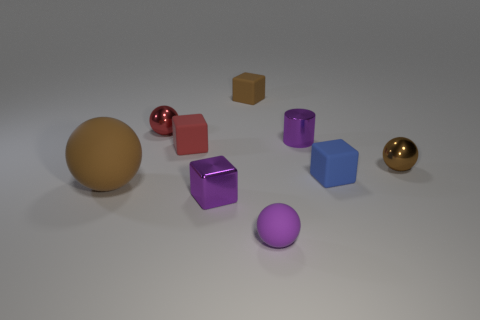Subtract all brown matte cubes. How many cubes are left? 3 Subtract all gray cylinders. How many brown spheres are left? 2 Add 1 tiny metallic things. How many objects exist? 10 Subtract all purple balls. How many balls are left? 3 Subtract all cylinders. How many objects are left? 8 Subtract 1 balls. How many balls are left? 3 Subtract 0 yellow balls. How many objects are left? 9 Subtract all blue spheres. Subtract all yellow cylinders. How many spheres are left? 4 Subtract all brown rubber cylinders. Subtract all purple metallic things. How many objects are left? 7 Add 7 blue matte blocks. How many blue matte blocks are left? 8 